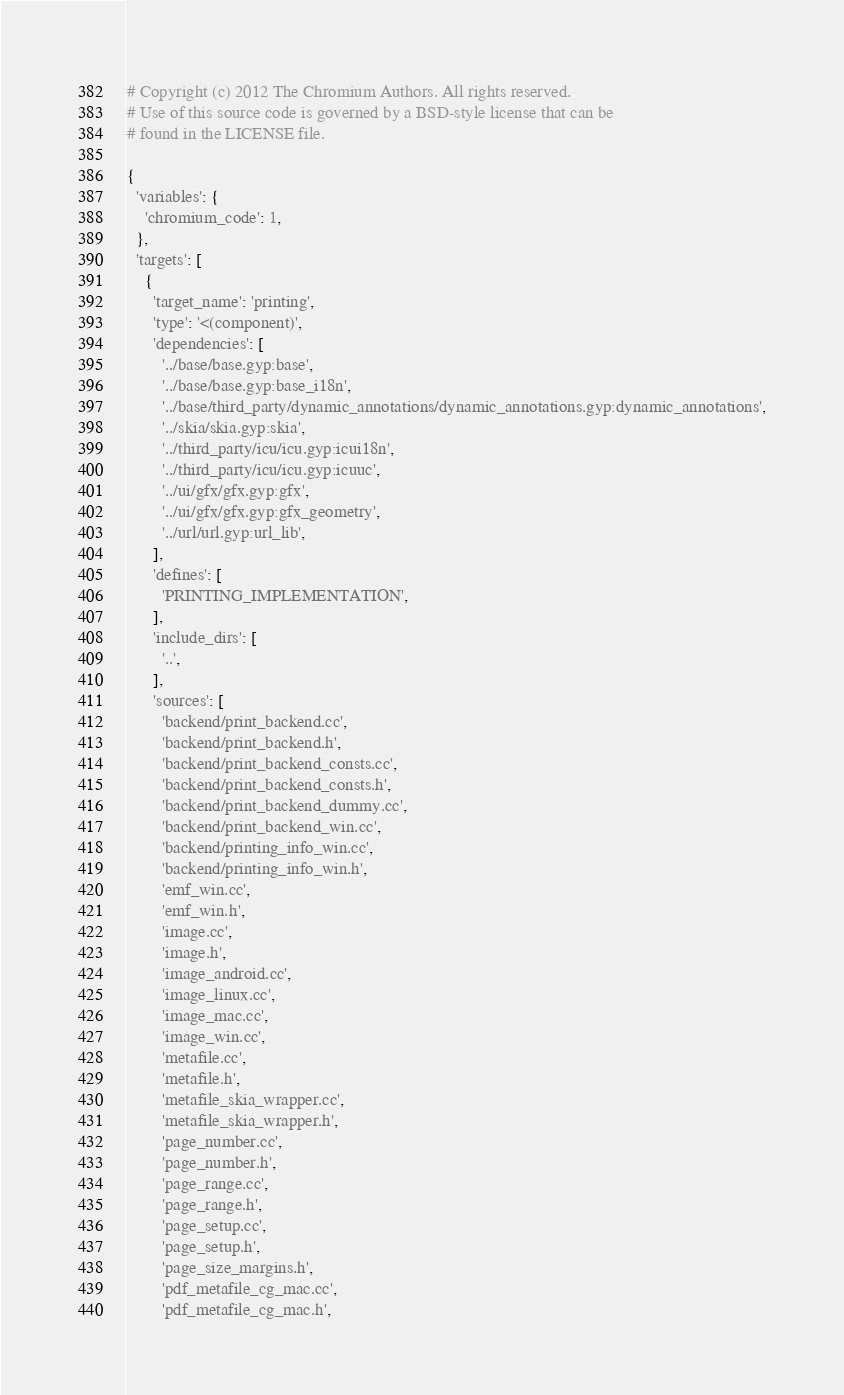<code> <loc_0><loc_0><loc_500><loc_500><_Python_># Copyright (c) 2012 The Chromium Authors. All rights reserved.
# Use of this source code is governed by a BSD-style license that can be
# found in the LICENSE file.

{
  'variables': {
    'chromium_code': 1,
  },
  'targets': [
    {
      'target_name': 'printing',
      'type': '<(component)',
      'dependencies': [
        '../base/base.gyp:base',
        '../base/base.gyp:base_i18n',
        '../base/third_party/dynamic_annotations/dynamic_annotations.gyp:dynamic_annotations',
        '../skia/skia.gyp:skia',
        '../third_party/icu/icu.gyp:icui18n',
        '../third_party/icu/icu.gyp:icuuc',
        '../ui/gfx/gfx.gyp:gfx',
        '../ui/gfx/gfx.gyp:gfx_geometry',
        '../url/url.gyp:url_lib',
      ],
      'defines': [
        'PRINTING_IMPLEMENTATION',
      ],
      'include_dirs': [
        '..',
      ],
      'sources': [
        'backend/print_backend.cc',
        'backend/print_backend.h',
        'backend/print_backend_consts.cc',
        'backend/print_backend_consts.h',
        'backend/print_backend_dummy.cc',
        'backend/print_backend_win.cc',
        'backend/printing_info_win.cc',
        'backend/printing_info_win.h',
        'emf_win.cc',
        'emf_win.h',
        'image.cc',
        'image.h',
        'image_android.cc',
        'image_linux.cc',
        'image_mac.cc',
        'image_win.cc',
        'metafile.cc',
        'metafile.h',
        'metafile_skia_wrapper.cc',
        'metafile_skia_wrapper.h',
        'page_number.cc',
        'page_number.h',
        'page_range.cc',
        'page_range.h',
        'page_setup.cc',
        'page_setup.h',
        'page_size_margins.h',
        'pdf_metafile_cg_mac.cc',
        'pdf_metafile_cg_mac.h',</code> 